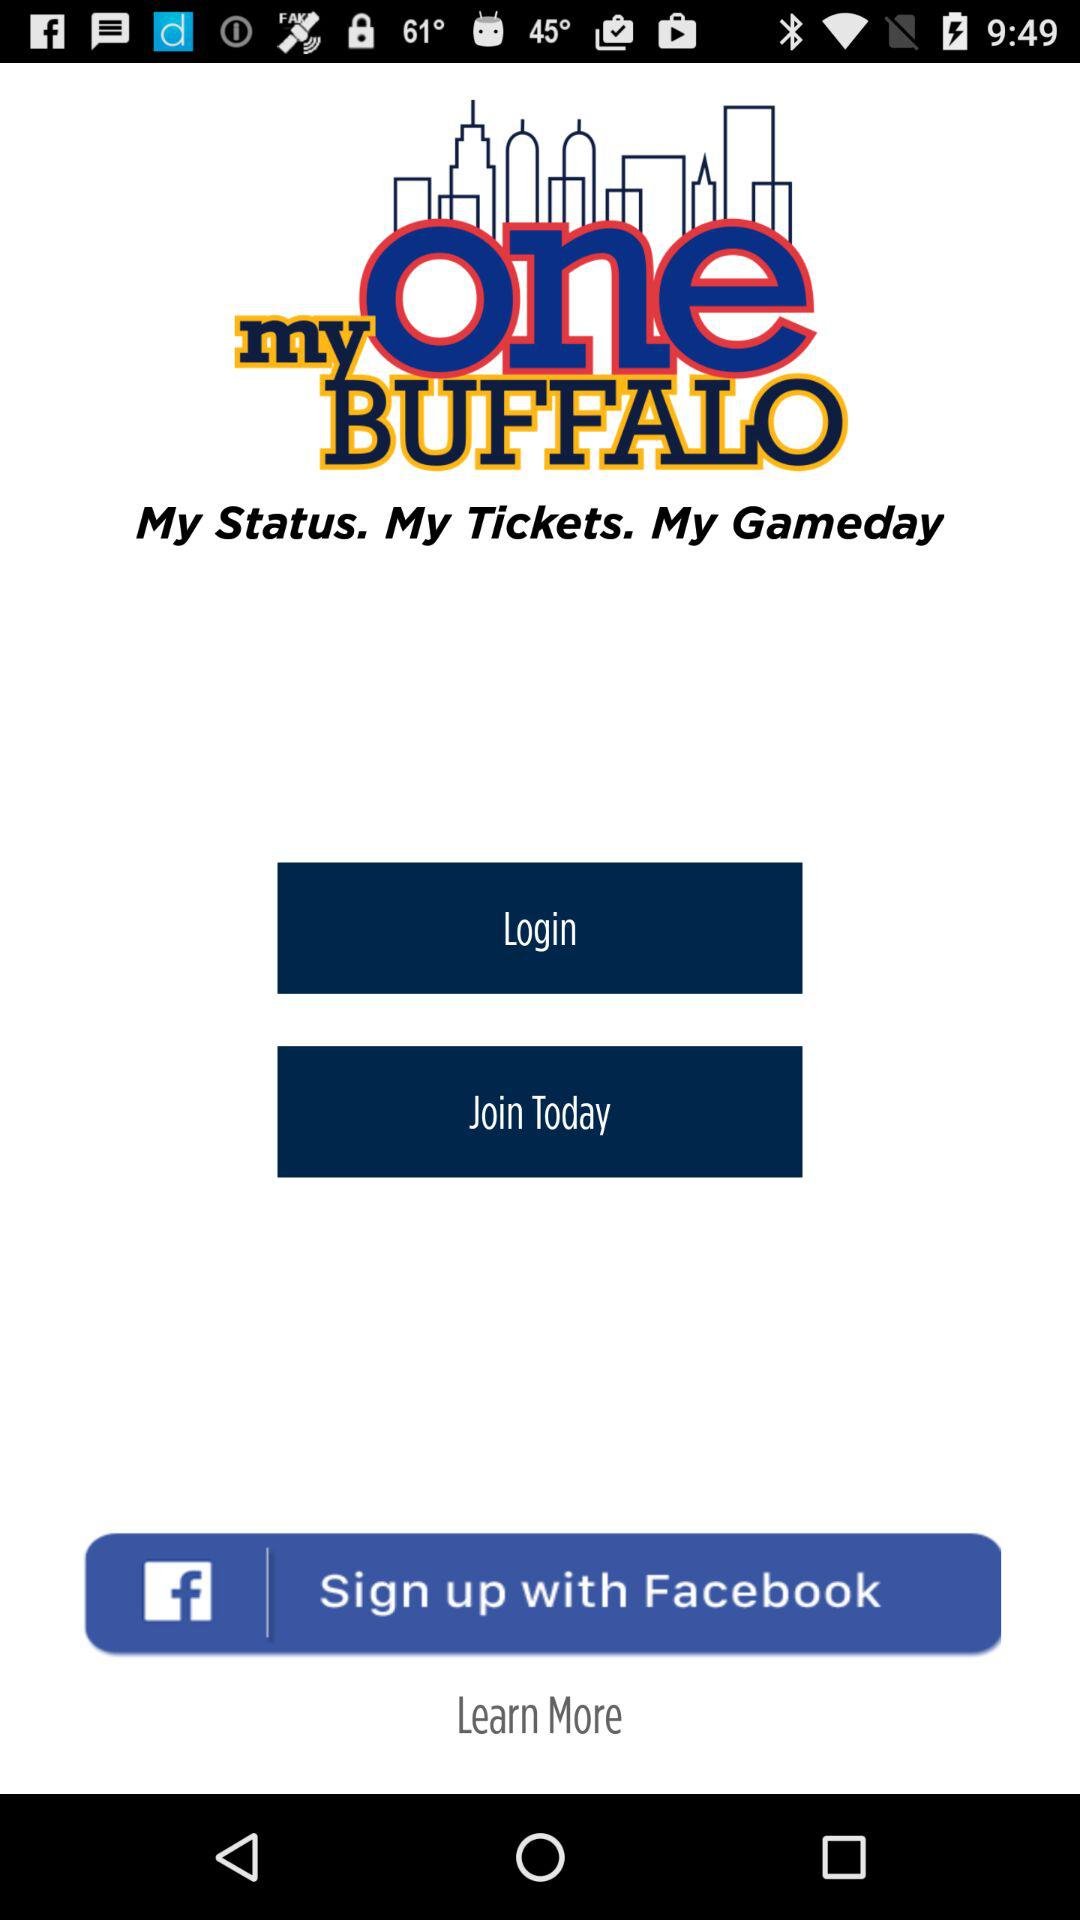How can we login?
When the provided information is insufficient, respond with <no answer>. <no answer> 